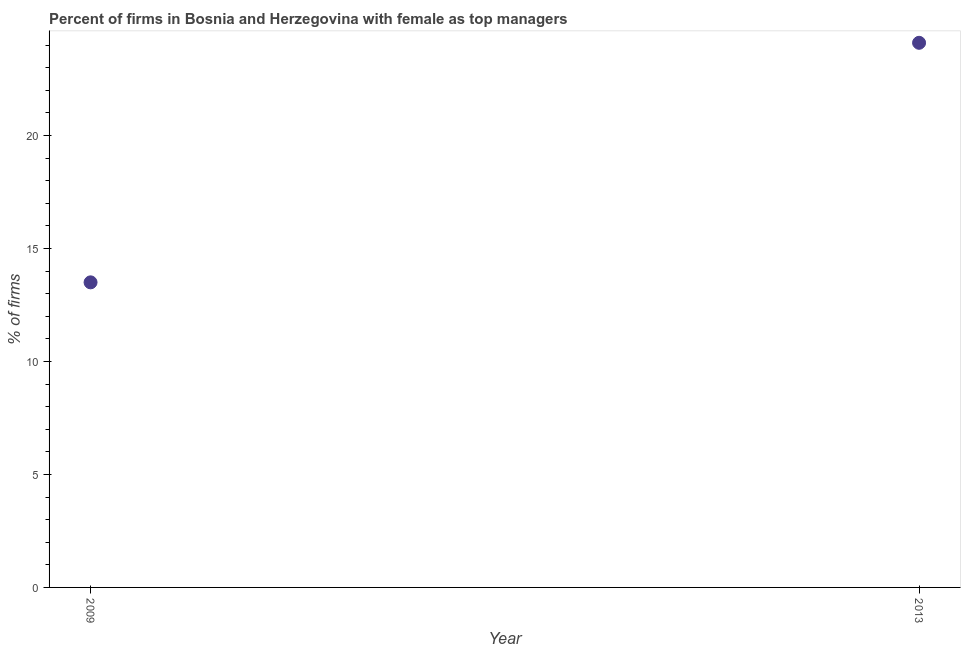What is the percentage of firms with female as top manager in 2009?
Make the answer very short. 13.5. Across all years, what is the maximum percentage of firms with female as top manager?
Offer a terse response. 24.1. Across all years, what is the minimum percentage of firms with female as top manager?
Offer a very short reply. 13.5. In which year was the percentage of firms with female as top manager maximum?
Offer a very short reply. 2013. What is the sum of the percentage of firms with female as top manager?
Make the answer very short. 37.6. What is the difference between the percentage of firms with female as top manager in 2009 and 2013?
Give a very brief answer. -10.6. What is the average percentage of firms with female as top manager per year?
Provide a succinct answer. 18.8. What is the median percentage of firms with female as top manager?
Provide a succinct answer. 18.8. Do a majority of the years between 2009 and 2013 (inclusive) have percentage of firms with female as top manager greater than 6 %?
Make the answer very short. Yes. What is the ratio of the percentage of firms with female as top manager in 2009 to that in 2013?
Ensure brevity in your answer.  0.56. Is the percentage of firms with female as top manager in 2009 less than that in 2013?
Make the answer very short. Yes. In how many years, is the percentage of firms with female as top manager greater than the average percentage of firms with female as top manager taken over all years?
Offer a very short reply. 1. How many years are there in the graph?
Ensure brevity in your answer.  2. What is the title of the graph?
Your response must be concise. Percent of firms in Bosnia and Herzegovina with female as top managers. What is the label or title of the Y-axis?
Your answer should be very brief. % of firms. What is the % of firms in 2009?
Offer a very short reply. 13.5. What is the % of firms in 2013?
Give a very brief answer. 24.1. What is the ratio of the % of firms in 2009 to that in 2013?
Provide a succinct answer. 0.56. 